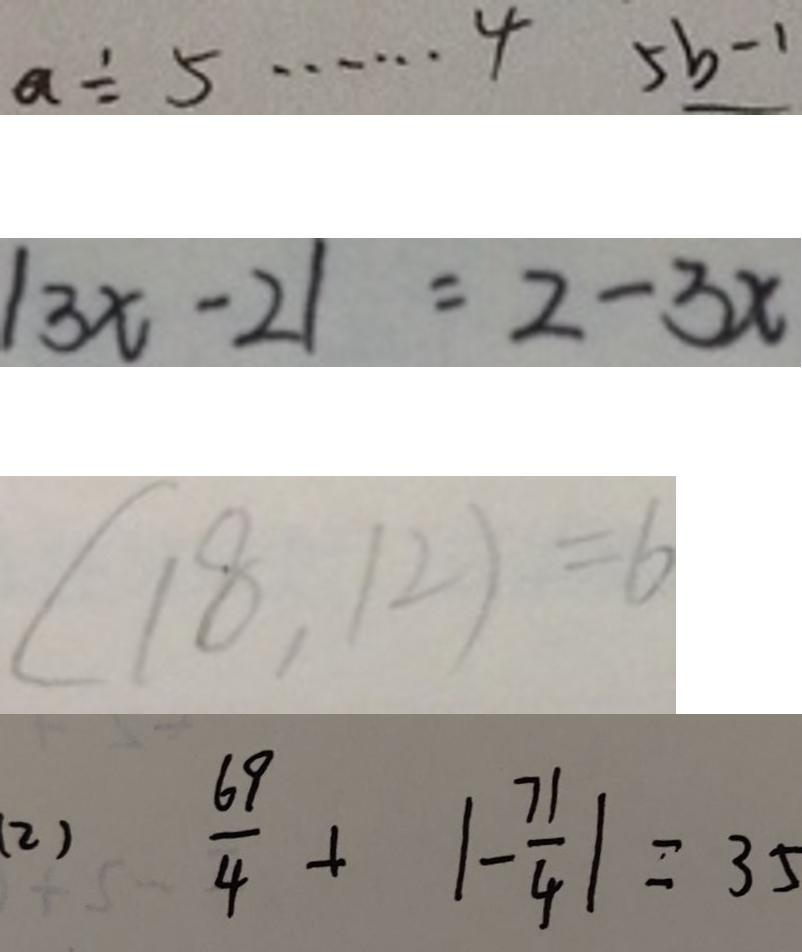<formula> <loc_0><loc_0><loc_500><loc_500>a \div 5 \cdots 4 5 b - 1 
 \vert 3 x - 2 \vert = 2 - 3 x 
 ( 1 8 , 1 2 ) = 6 
 ( 2 ) \frac { 6 9 } { 4 } + \vert - \frac { 7 1 } { 4 } \vert = 3 5</formula> 